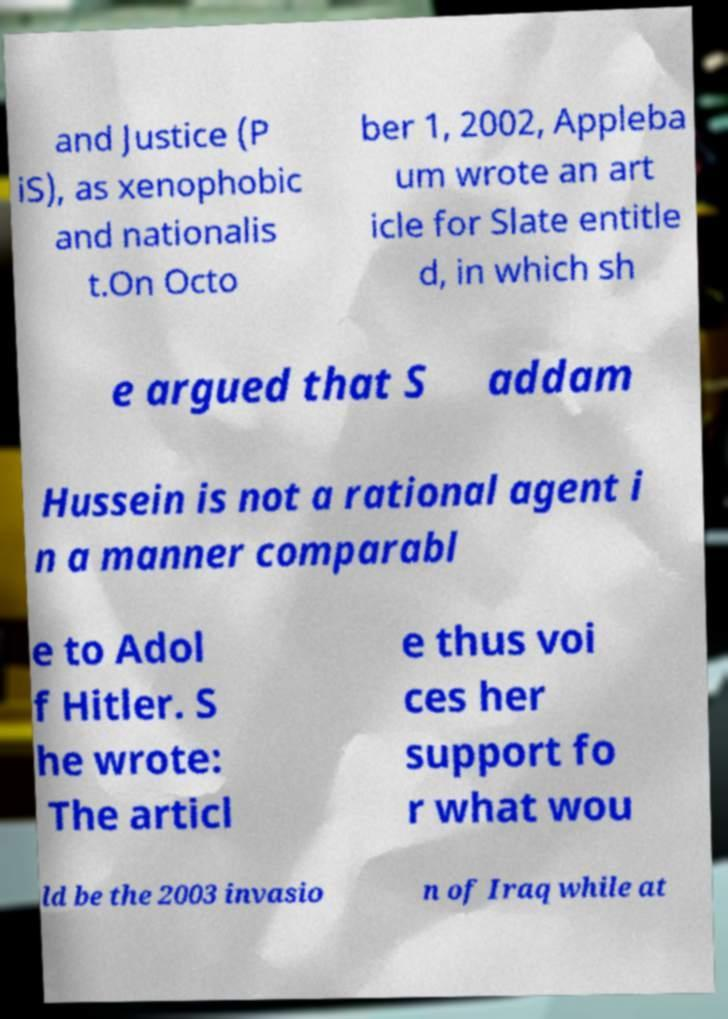Can you accurately transcribe the text from the provided image for me? and Justice (P iS), as xenophobic and nationalis t.On Octo ber 1, 2002, Appleba um wrote an art icle for Slate entitle d, in which sh e argued that S addam Hussein is not a rational agent i n a manner comparabl e to Adol f Hitler. S he wrote: The articl e thus voi ces her support fo r what wou ld be the 2003 invasio n of Iraq while at 